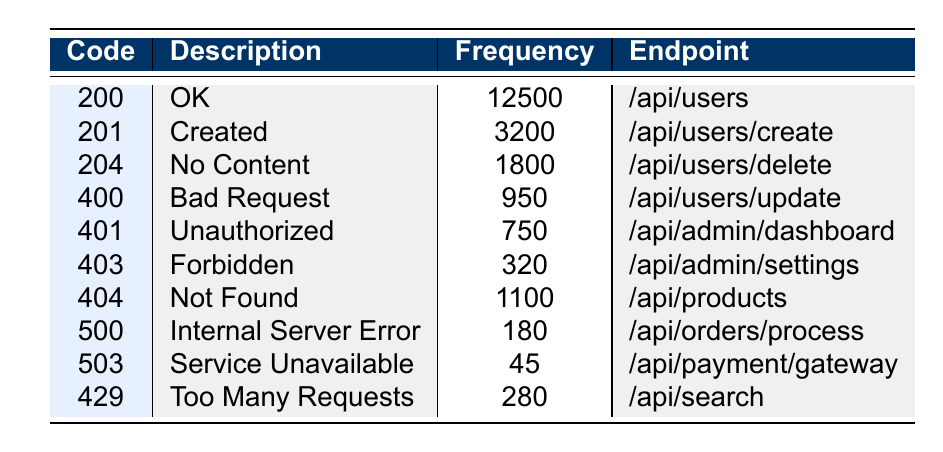What is the frequency of the 'Not Found' response code? The table shows the frequency for the 'Not Found' response code (404), which is listed as 1100.
Answer: 1100 Which endpoint has the highest frequency of responses? The 'OK' response code (200) has the highest frequency, with a total of 12500 occurrences, associated with the endpoint '/api/users'.
Answer: /api/users How many responses had a frequency of less than 300? The table provides the 'Service Unavailable' (503) with a frequency of 45, and 'Forbidden' (403) with a frequency of 320, thus there is only one response with a frequency of less than 300.
Answer: 1 What is the total frequency of success status codes (200, 201, 204)? Adding the frequencies of responses categorized as success: 12500 (200) + 3200 (201) + 1800 (204) equals 18500.
Answer: 18500 Is the 'Unauthorized' response code more frequent than the 'Bad Request' response code? The 'Unauthorized' response code (401) has a frequency of 750, which is greater than the 'Bad Request' response code (400) with a frequency of 950. Therefore, the statement is false.
Answer: No What are the two most common response codes? By looking at the frequencies, 'OK' (200) is the most common with 12500 instances, and 'Created' (201) is the second most common with 3200 instances.
Answer: 200 and 201 What is the difference in frequency between the 'No Content' and 'Internal Server Error' response codes? The 'No Content' response (204) has a frequency of 1800 and 'Internal Server Error' (500) has a frequency of 180. The difference is 1800 - 180 = 1620.
Answer: 1620 Which endpoint received the least responses? The 'Service Unavailable' code (503) has the lowest frequency of responses at 45, indicating it is linked to the endpoint '/api/payment/gateway'.
Answer: /api/payment/gateway What is the average frequency of the responses within the table? To find the average, sum all frequencies: 12500 + 3200 + 1800 + 950 + 750 + 320 + 1100 + 180 + 45 + 280 = 18825. There are 10 response codes in total, which gives an average of 18825 / 10 = 1882.5.
Answer: 1882.5 Are there more 'Too Many Requests' responses than 'Service Unavailable' responses? The 'Too Many Requests' response (429) has a frequency of 280, while the 'Service Unavailable' (503) has a frequency of 45. Since 280 is greater than 45, the answer is true.
Answer: Yes 